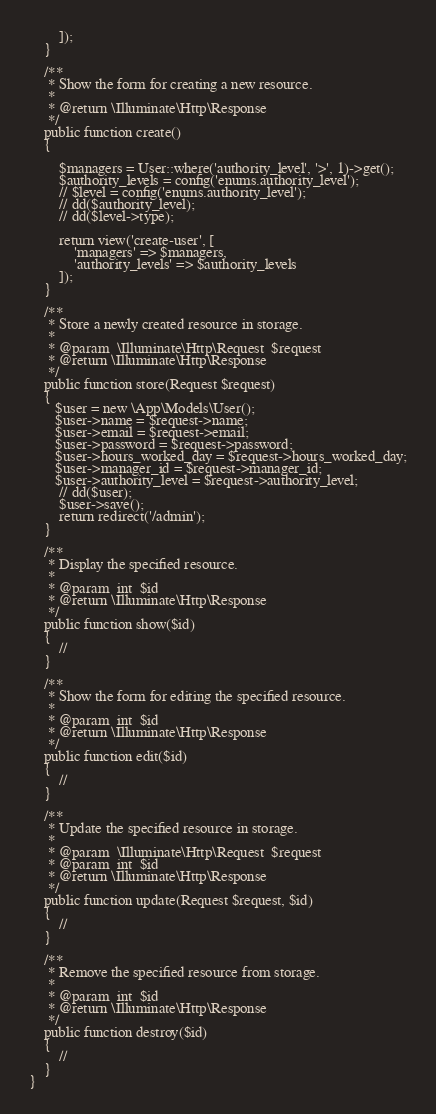<code> <loc_0><loc_0><loc_500><loc_500><_PHP_>
        ]);
    }

    /**
     * Show the form for creating a new resource.
     *
     * @return \Illuminate\Http\Response
     */
    public function create()
    {
        
        $managers = User::where('authority_level', '>', 1)->get();
        $authority_levels = config('enums.authority_level');
        // $level = config('enums.authority_level');
        // dd($authority_level);
        // dd($level->type);
 
        return view('create-user', [
            'managers' => $managers,
            'authority_levels' => $authority_levels
        ]);
    }

    /**
     * Store a newly created resource in storage.
     *
     * @param  \Illuminate\Http\Request  $request
     * @return \Illuminate\Http\Response
     */
    public function store(Request $request)
    {
       $user = new \App\Models\User();
       $user->name = $request->name;
       $user->email = $request->email;
       $user->password = $request->password;
       $user->hours_worked_day = $request->hours_worked_day;
       $user->manager_id = $request->manager_id;
       $user->authority_level = $request->authority_level;
        // dd($user);
        $user->save();
        return redirect('/admin');
    }

    /**
     * Display the specified resource.
     *
     * @param  int  $id
     * @return \Illuminate\Http\Response
     */
    public function show($id)
    {
        //
    }

    /**
     * Show the form for editing the specified resource.
     *
     * @param  int  $id
     * @return \Illuminate\Http\Response
     */
    public function edit($id)
    {
        //
    }

    /**
     * Update the specified resource in storage.
     *
     * @param  \Illuminate\Http\Request  $request
     * @param  int  $id
     * @return \Illuminate\Http\Response
     */
    public function update(Request $request, $id)
    {
        //
    }

    /**
     * Remove the specified resource from storage.
     *
     * @param  int  $id
     * @return \Illuminate\Http\Response
     */
    public function destroy($id)
    {
        //
    }
}
</code> 